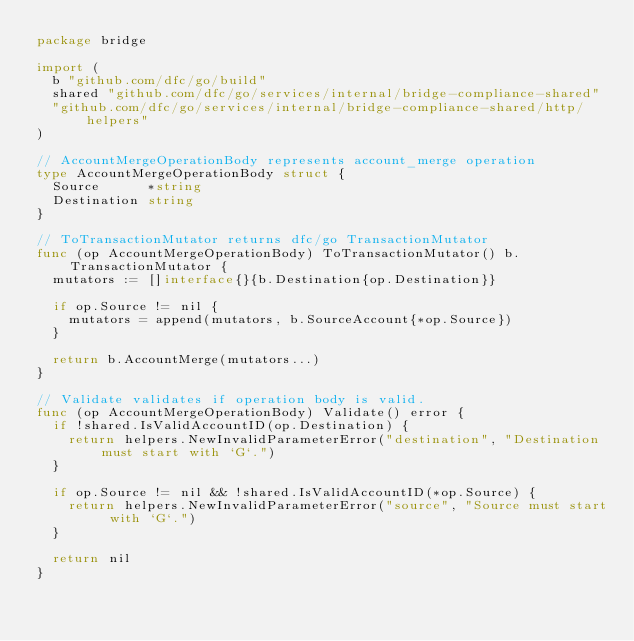Convert code to text. <code><loc_0><loc_0><loc_500><loc_500><_Go_>package bridge

import (
	b "github.com/dfc/go/build"
	shared "github.com/dfc/go/services/internal/bridge-compliance-shared"
	"github.com/dfc/go/services/internal/bridge-compliance-shared/http/helpers"
)

// AccountMergeOperationBody represents account_merge operation
type AccountMergeOperationBody struct {
	Source      *string
	Destination string
}

// ToTransactionMutator returns dfc/go TransactionMutator
func (op AccountMergeOperationBody) ToTransactionMutator() b.TransactionMutator {
	mutators := []interface{}{b.Destination{op.Destination}}

	if op.Source != nil {
		mutators = append(mutators, b.SourceAccount{*op.Source})
	}

	return b.AccountMerge(mutators...)
}

// Validate validates if operation body is valid.
func (op AccountMergeOperationBody) Validate() error {
	if !shared.IsValidAccountID(op.Destination) {
		return helpers.NewInvalidParameterError("destination", "Destination must start with `G`.")
	}

	if op.Source != nil && !shared.IsValidAccountID(*op.Source) {
		return helpers.NewInvalidParameterError("source", "Source must start with `G`.")
	}

	return nil
}
</code> 